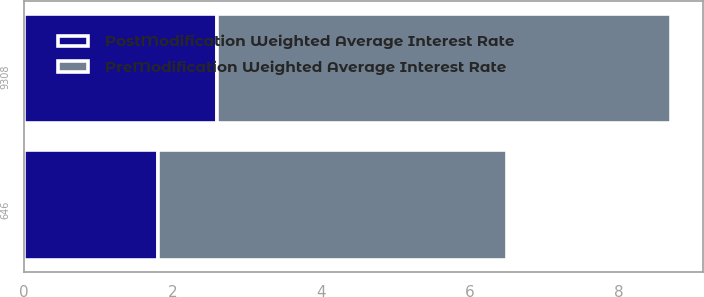Convert chart. <chart><loc_0><loc_0><loc_500><loc_500><stacked_bar_chart><ecel><fcel>9308<fcel>646<nl><fcel>PreModification Weighted Average Interest Rate<fcel>6.1<fcel>4.7<nl><fcel>PostModification Weighted Average Interest Rate<fcel>2.6<fcel>1.8<nl></chart> 